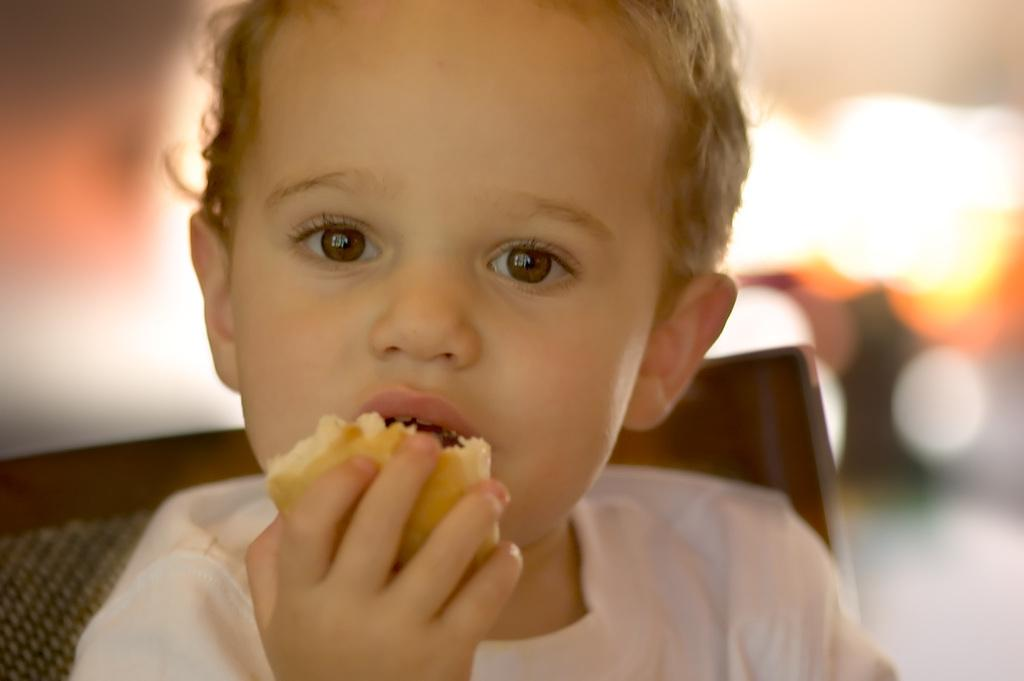What is the main subject of the image? The main subject of the image is a kid. What is the kid holding in the image? The kid is holding an eatable thing. Is there any furniture visible in the image? Yes, there is a chair in the image. How would you describe the background of the image? The background of the image is blurred. Can you tell me what type of guitar the kid is playing in the image? There is no guitar present in the image; the kid is holding an eatable thing. How many pears can be seen on the chair in the image? There are no pears visible in the image; only a chair is present. 